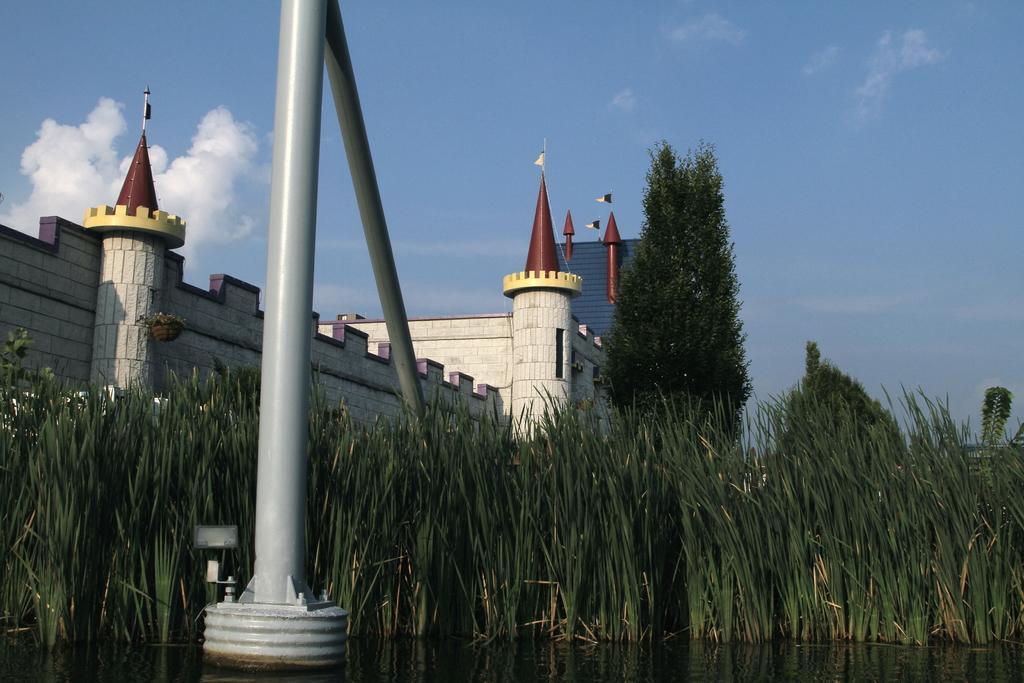In one or two sentences, can you explain what this image depicts? This image is clicked outside. There is a building in the middle. There is a tree in the middle. There is grass at the bottom. There is sky at the top. 